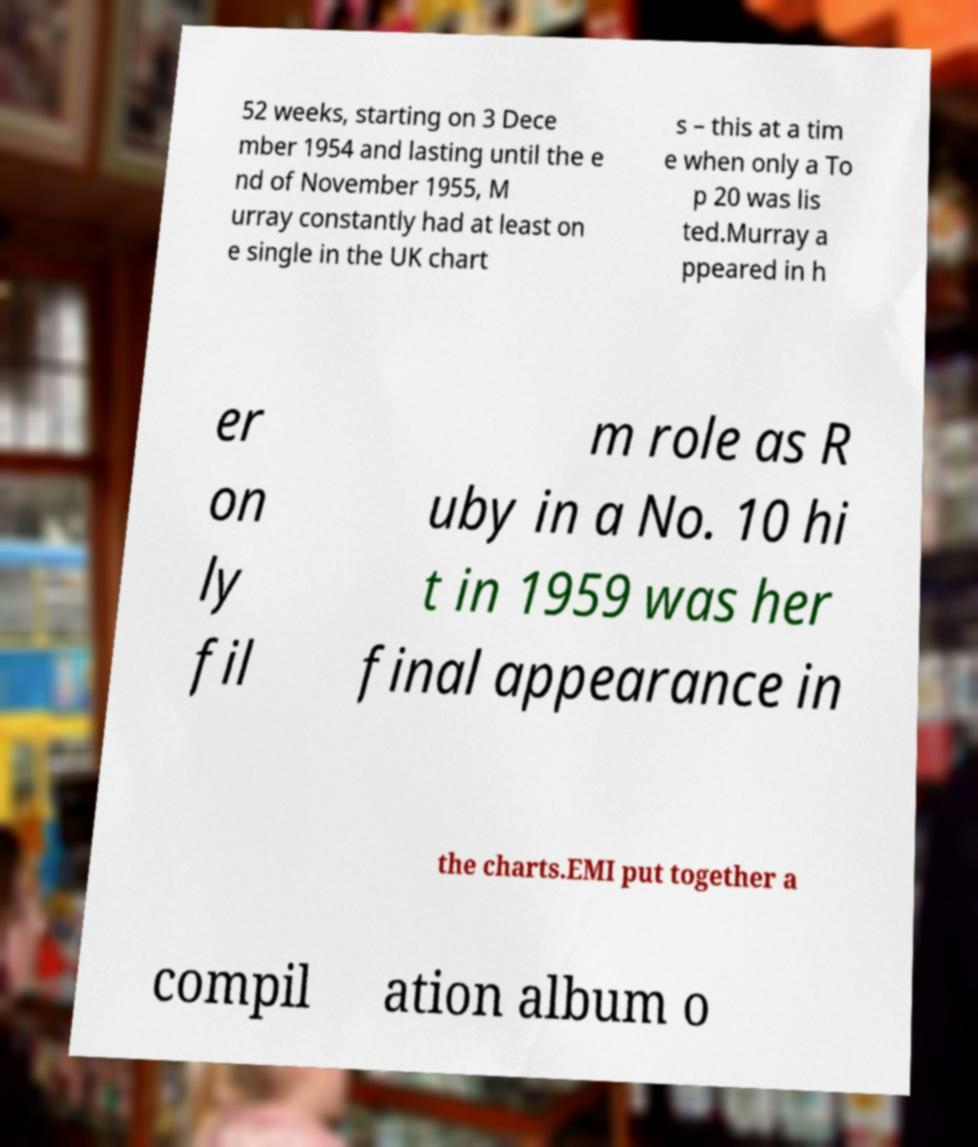I need the written content from this picture converted into text. Can you do that? 52 weeks, starting on 3 Dece mber 1954 and lasting until the e nd of November 1955, M urray constantly had at least on e single in the UK chart s – this at a tim e when only a To p 20 was lis ted.Murray a ppeared in h er on ly fil m role as R uby in a No. 10 hi t in 1959 was her final appearance in the charts.EMI put together a compil ation album o 